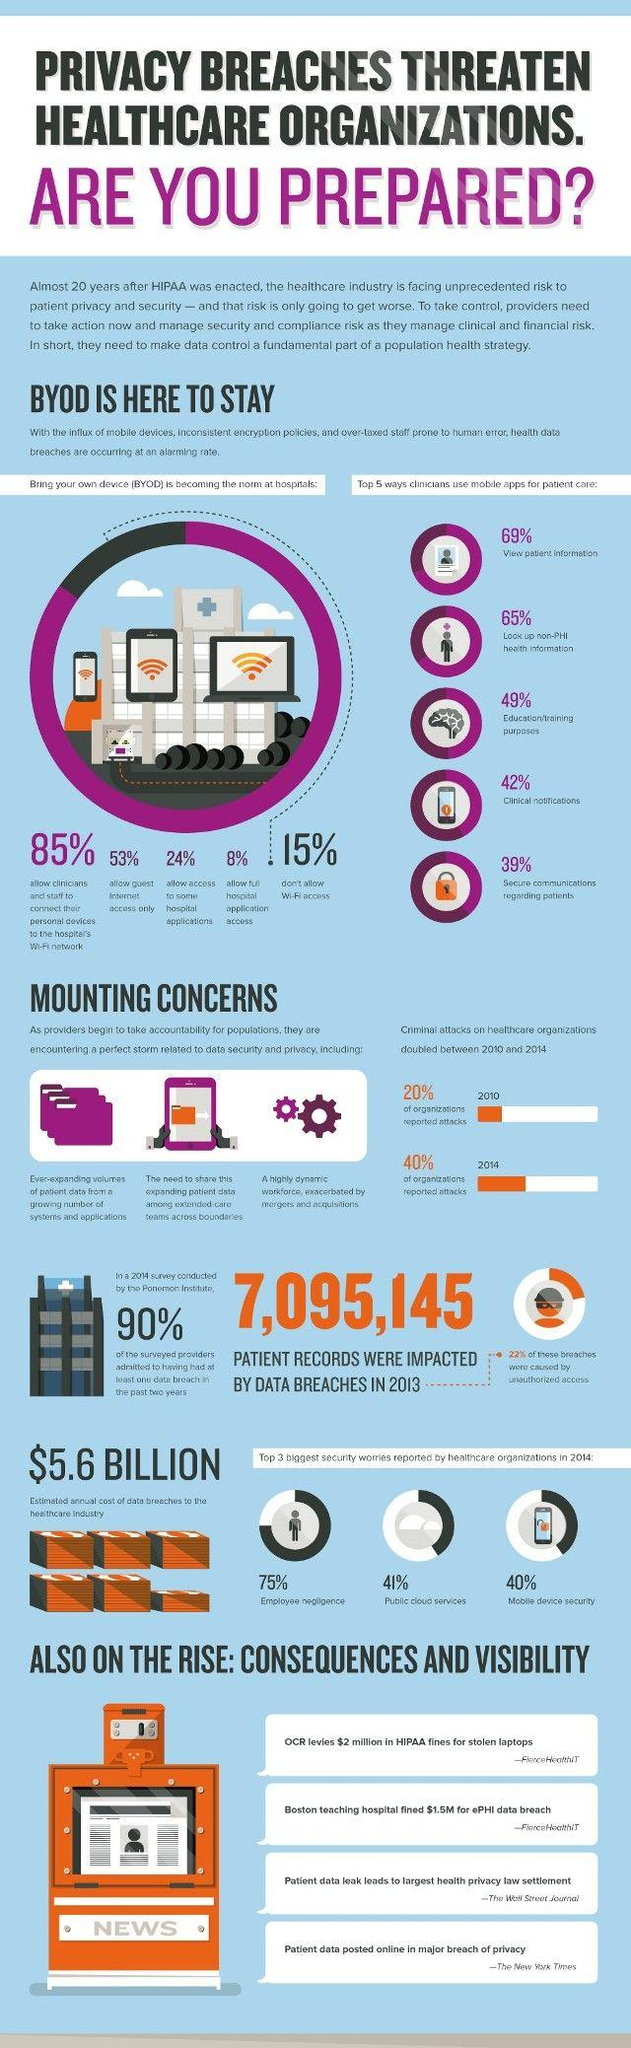Specify some key components in this picture. Approximately 76% of hospitals in the United States do not allow access to certain hospital applications. In the survey, 92% of hospitals did not allow full access to their hospital application to the IT team. According to the given information, 78% of breaches were not caused by unauthorized access. In the years 2010 and 2014, 60% of organizations reported being attacked. 